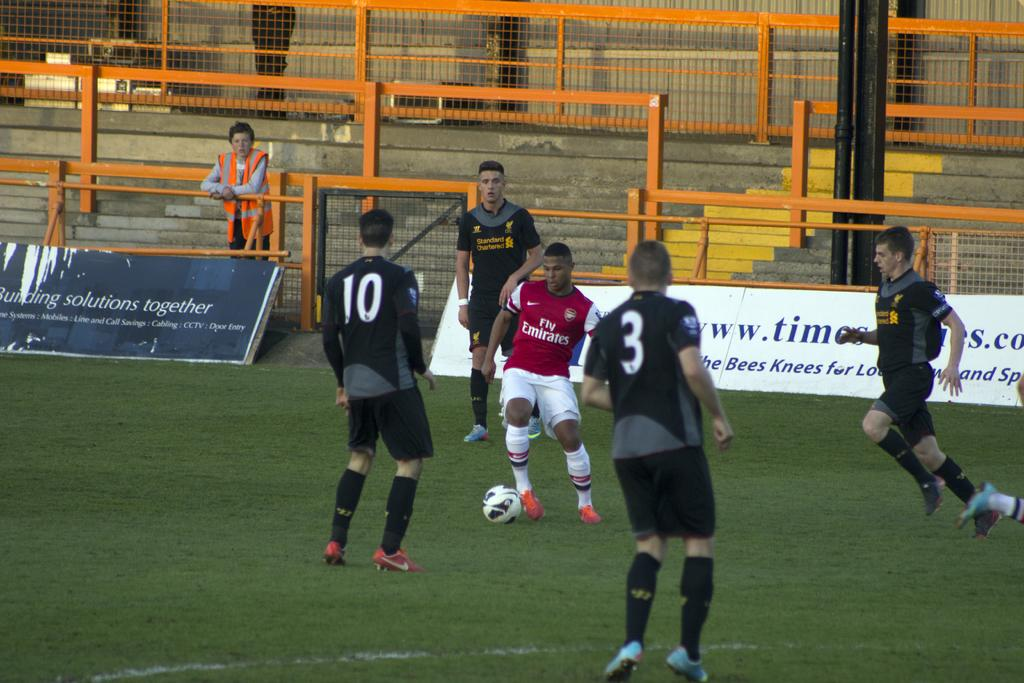Provide a one-sentence caption for the provided image. a team of soccer players, one has #10 on the jersey and other has a 3. 